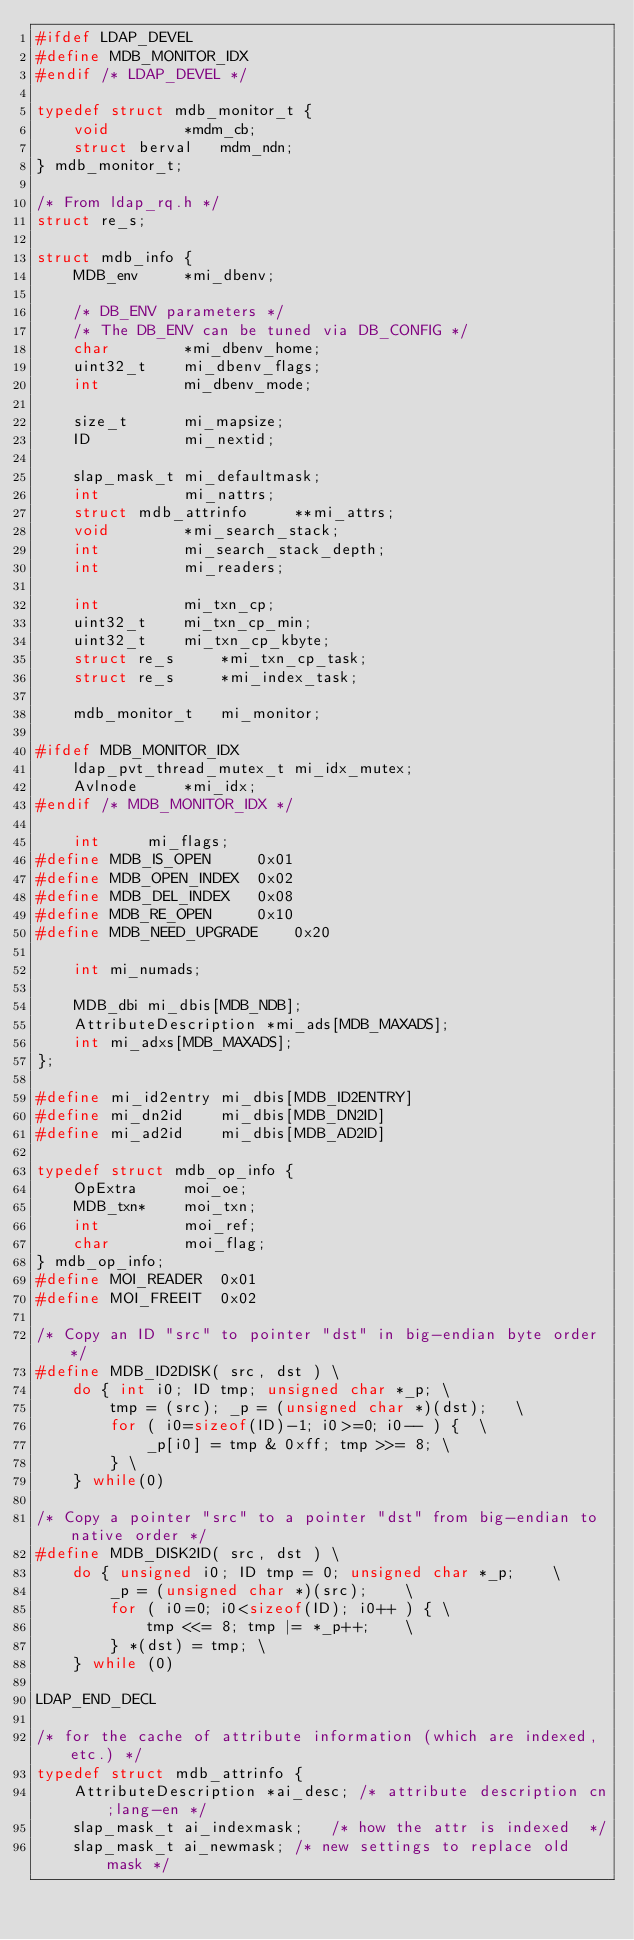Convert code to text. <code><loc_0><loc_0><loc_500><loc_500><_C_>#ifdef LDAP_DEVEL
#define MDB_MONITOR_IDX
#endif /* LDAP_DEVEL */

typedef struct mdb_monitor_t {
	void		*mdm_cb;
	struct berval	mdm_ndn;
} mdb_monitor_t;

/* From ldap_rq.h */
struct re_s;

struct mdb_info {
	MDB_env		*mi_dbenv;

	/* DB_ENV parameters */
	/* The DB_ENV can be tuned via DB_CONFIG */
	char		*mi_dbenv_home;
	uint32_t	mi_dbenv_flags;
	int			mi_dbenv_mode;

	size_t		mi_mapsize;
	ID			mi_nextid;

	slap_mask_t	mi_defaultmask;
	int			mi_nattrs;
	struct mdb_attrinfo		**mi_attrs;
	void		*mi_search_stack;
	int			mi_search_stack_depth;
	int			mi_readers;

	int			mi_txn_cp;
	uint32_t	mi_txn_cp_min;
	uint32_t	mi_txn_cp_kbyte;
	struct re_s		*mi_txn_cp_task;
	struct re_s		*mi_index_task;

	mdb_monitor_t	mi_monitor;

#ifdef MDB_MONITOR_IDX
	ldap_pvt_thread_mutex_t	mi_idx_mutex;
	Avlnode		*mi_idx;
#endif /* MDB_MONITOR_IDX */

	int		mi_flags;
#define	MDB_IS_OPEN		0x01
#define	MDB_OPEN_INDEX	0x02
#define	MDB_DEL_INDEX	0x08
#define	MDB_RE_OPEN		0x10
#define	MDB_NEED_UPGRADE	0x20

	int mi_numads;

	MDB_dbi	mi_dbis[MDB_NDB];
	AttributeDescription *mi_ads[MDB_MAXADS];
	int mi_adxs[MDB_MAXADS];
};

#define mi_id2entry	mi_dbis[MDB_ID2ENTRY]
#define mi_dn2id	mi_dbis[MDB_DN2ID]
#define mi_ad2id	mi_dbis[MDB_AD2ID]

typedef struct mdb_op_info {
	OpExtra		moi_oe;
	MDB_txn*	moi_txn;
	int			moi_ref;
	char		moi_flag;
} mdb_op_info;
#define MOI_READER	0x01
#define MOI_FREEIT	0x02

/* Copy an ID "src" to pointer "dst" in big-endian byte order */
#define MDB_ID2DISK( src, dst )	\
	do { int i0; ID tmp; unsigned char *_p;	\
		tmp = (src); _p = (unsigned char *)(dst);	\
		for ( i0=sizeof(ID)-1; i0>=0; i0-- ) {	\
			_p[i0] = tmp & 0xff; tmp >>= 8;	\
		} \
	} while(0)

/* Copy a pointer "src" to a pointer "dst" from big-endian to native order */
#define MDB_DISK2ID( src, dst ) \
	do { unsigned i0; ID tmp = 0; unsigned char *_p;	\
		_p = (unsigned char *)(src);	\
		for ( i0=0; i0<sizeof(ID); i0++ ) {	\
			tmp <<= 8; tmp |= *_p++;	\
		} *(dst) = tmp; \
	} while (0)

LDAP_END_DECL

/* for the cache of attribute information (which are indexed, etc.) */
typedef struct mdb_attrinfo {
	AttributeDescription *ai_desc; /* attribute description cn;lang-en */
	slap_mask_t ai_indexmask;	/* how the attr is indexed	*/
	slap_mask_t ai_newmask;	/* new settings to replace old mask */</code> 